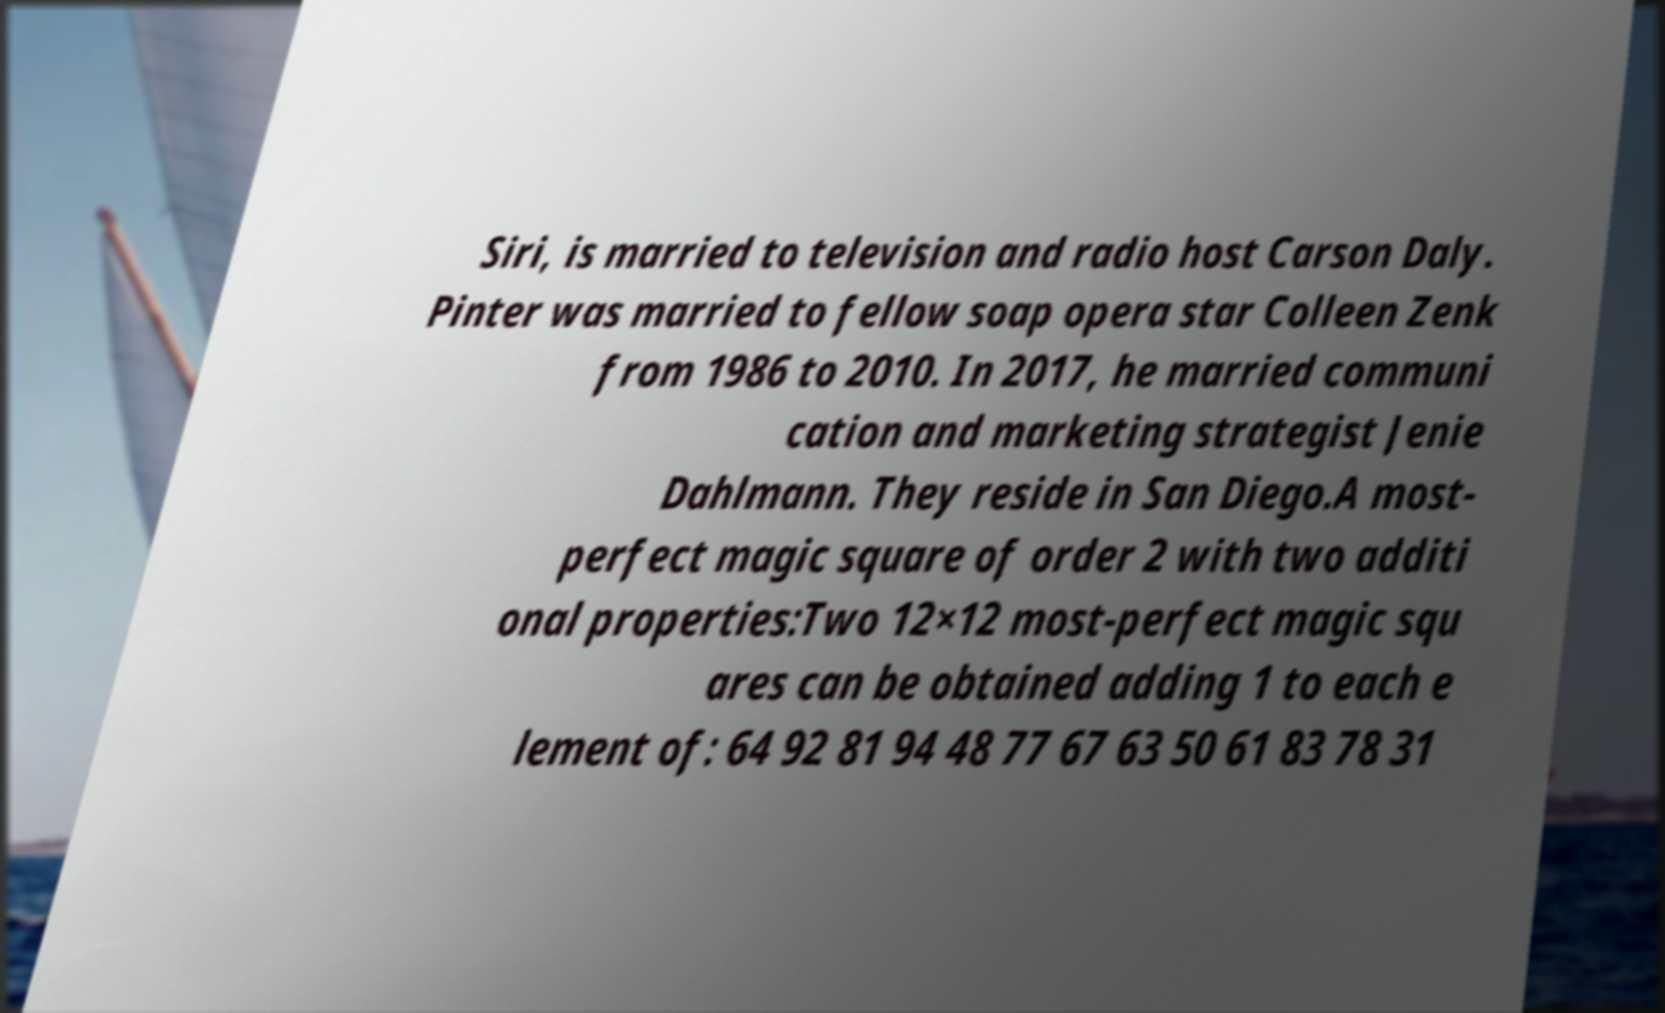What messages or text are displayed in this image? I need them in a readable, typed format. Siri, is married to television and radio host Carson Daly. Pinter was married to fellow soap opera star Colleen Zenk from 1986 to 2010. In 2017, he married communi cation and marketing strategist Jenie Dahlmann. They reside in San Diego.A most- perfect magic square of order 2 with two additi onal properties:Two 12×12 most-perfect magic squ ares can be obtained adding 1 to each e lement of: 64 92 81 94 48 77 67 63 50 61 83 78 31 